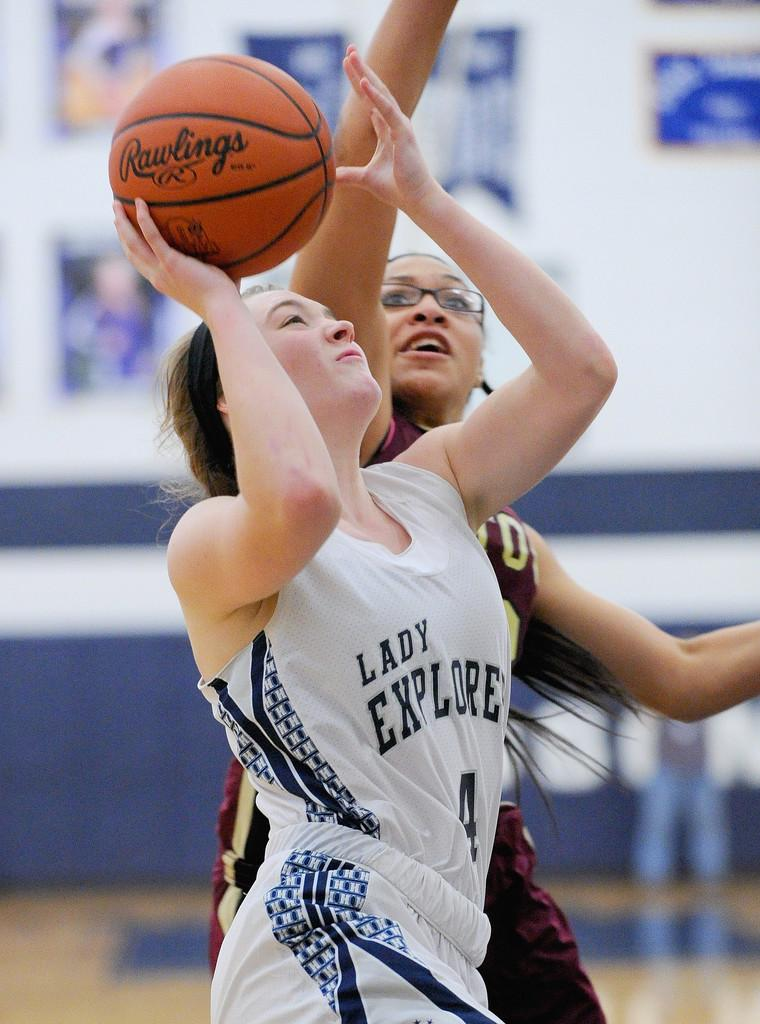<image>
Create a compact narrative representing the image presented. a person playing a game with with the words Lady Explorer on her shirt 